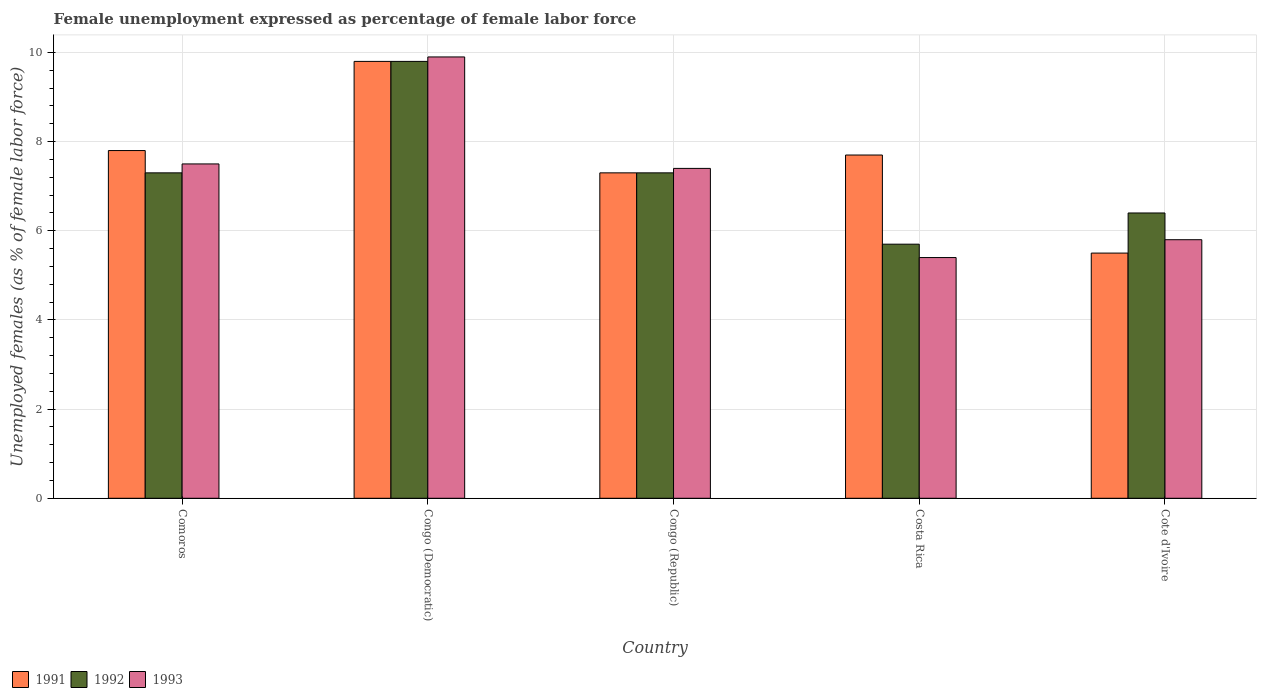How many different coloured bars are there?
Provide a succinct answer. 3. Are the number of bars per tick equal to the number of legend labels?
Offer a very short reply. Yes. What is the label of the 3rd group of bars from the left?
Your answer should be very brief. Congo (Republic). In how many cases, is the number of bars for a given country not equal to the number of legend labels?
Offer a terse response. 0. What is the unemployment in females in in 1993 in Congo (Republic)?
Your answer should be very brief. 7.4. Across all countries, what is the maximum unemployment in females in in 1992?
Your response must be concise. 9.8. Across all countries, what is the minimum unemployment in females in in 1992?
Your response must be concise. 5.7. In which country was the unemployment in females in in 1992 maximum?
Ensure brevity in your answer.  Congo (Democratic). What is the total unemployment in females in in 1992 in the graph?
Give a very brief answer. 36.5. What is the difference between the unemployment in females in in 1991 in Congo (Democratic) and that in Congo (Republic)?
Keep it short and to the point. 2.5. What is the difference between the unemployment in females in in 1992 in Congo (Republic) and the unemployment in females in in 1993 in Cote d'Ivoire?
Keep it short and to the point. 1.5. What is the average unemployment in females in in 1991 per country?
Provide a short and direct response. 7.62. What is the difference between the unemployment in females in of/in 1991 and unemployment in females in of/in 1993 in Comoros?
Make the answer very short. 0.3. What is the ratio of the unemployment in females in in 1991 in Comoros to that in Congo (Democratic)?
Your answer should be very brief. 0.8. Is the difference between the unemployment in females in in 1991 in Comoros and Congo (Republic) greater than the difference between the unemployment in females in in 1993 in Comoros and Congo (Republic)?
Keep it short and to the point. Yes. What is the difference between the highest and the second highest unemployment in females in in 1993?
Offer a terse response. 2.5. What is the difference between the highest and the lowest unemployment in females in in 1993?
Provide a succinct answer. 4.5. What does the 1st bar from the left in Congo (Republic) represents?
Provide a short and direct response. 1991. Are all the bars in the graph horizontal?
Ensure brevity in your answer.  No. What is the difference between two consecutive major ticks on the Y-axis?
Your answer should be compact. 2. Does the graph contain grids?
Your answer should be compact. Yes. Where does the legend appear in the graph?
Your answer should be compact. Bottom left. How many legend labels are there?
Ensure brevity in your answer.  3. What is the title of the graph?
Provide a short and direct response. Female unemployment expressed as percentage of female labor force. What is the label or title of the X-axis?
Make the answer very short. Country. What is the label or title of the Y-axis?
Your response must be concise. Unemployed females (as % of female labor force). What is the Unemployed females (as % of female labor force) of 1991 in Comoros?
Ensure brevity in your answer.  7.8. What is the Unemployed females (as % of female labor force) in 1992 in Comoros?
Your response must be concise. 7.3. What is the Unemployed females (as % of female labor force) in 1991 in Congo (Democratic)?
Your response must be concise. 9.8. What is the Unemployed females (as % of female labor force) of 1992 in Congo (Democratic)?
Your answer should be very brief. 9.8. What is the Unemployed females (as % of female labor force) in 1993 in Congo (Democratic)?
Offer a very short reply. 9.9. What is the Unemployed females (as % of female labor force) of 1991 in Congo (Republic)?
Provide a succinct answer. 7.3. What is the Unemployed females (as % of female labor force) in 1992 in Congo (Republic)?
Make the answer very short. 7.3. What is the Unemployed females (as % of female labor force) in 1993 in Congo (Republic)?
Your answer should be compact. 7.4. What is the Unemployed females (as % of female labor force) in 1991 in Costa Rica?
Your answer should be very brief. 7.7. What is the Unemployed females (as % of female labor force) of 1992 in Costa Rica?
Offer a very short reply. 5.7. What is the Unemployed females (as % of female labor force) in 1993 in Costa Rica?
Make the answer very short. 5.4. What is the Unemployed females (as % of female labor force) of 1992 in Cote d'Ivoire?
Keep it short and to the point. 6.4. What is the Unemployed females (as % of female labor force) of 1993 in Cote d'Ivoire?
Offer a very short reply. 5.8. Across all countries, what is the maximum Unemployed females (as % of female labor force) in 1991?
Your answer should be very brief. 9.8. Across all countries, what is the maximum Unemployed females (as % of female labor force) in 1992?
Provide a short and direct response. 9.8. Across all countries, what is the maximum Unemployed females (as % of female labor force) in 1993?
Make the answer very short. 9.9. Across all countries, what is the minimum Unemployed females (as % of female labor force) of 1991?
Ensure brevity in your answer.  5.5. Across all countries, what is the minimum Unemployed females (as % of female labor force) of 1992?
Offer a very short reply. 5.7. Across all countries, what is the minimum Unemployed females (as % of female labor force) of 1993?
Ensure brevity in your answer.  5.4. What is the total Unemployed females (as % of female labor force) in 1991 in the graph?
Ensure brevity in your answer.  38.1. What is the total Unemployed females (as % of female labor force) in 1992 in the graph?
Provide a short and direct response. 36.5. What is the difference between the Unemployed females (as % of female labor force) of 1991 in Comoros and that in Congo (Democratic)?
Your response must be concise. -2. What is the difference between the Unemployed females (as % of female labor force) in 1992 in Comoros and that in Congo (Democratic)?
Your answer should be very brief. -2.5. What is the difference between the Unemployed females (as % of female labor force) in 1993 in Comoros and that in Congo (Democratic)?
Your response must be concise. -2.4. What is the difference between the Unemployed females (as % of female labor force) in 1991 in Comoros and that in Congo (Republic)?
Provide a succinct answer. 0.5. What is the difference between the Unemployed females (as % of female labor force) of 1992 in Comoros and that in Congo (Republic)?
Offer a very short reply. 0. What is the difference between the Unemployed females (as % of female labor force) of 1993 in Comoros and that in Congo (Republic)?
Provide a succinct answer. 0.1. What is the difference between the Unemployed females (as % of female labor force) of 1991 in Comoros and that in Costa Rica?
Ensure brevity in your answer.  0.1. What is the difference between the Unemployed females (as % of female labor force) in 1992 in Comoros and that in Costa Rica?
Your answer should be very brief. 1.6. What is the difference between the Unemployed females (as % of female labor force) of 1993 in Congo (Democratic) and that in Costa Rica?
Your answer should be compact. 4.5. What is the difference between the Unemployed females (as % of female labor force) in 1993 in Congo (Democratic) and that in Cote d'Ivoire?
Your answer should be very brief. 4.1. What is the difference between the Unemployed females (as % of female labor force) in 1991 in Congo (Republic) and that in Costa Rica?
Make the answer very short. -0.4. What is the difference between the Unemployed females (as % of female labor force) in 1992 in Congo (Republic) and that in Costa Rica?
Offer a very short reply. 1.6. What is the difference between the Unemployed females (as % of female labor force) of 1993 in Congo (Republic) and that in Costa Rica?
Your response must be concise. 2. What is the difference between the Unemployed females (as % of female labor force) of 1992 in Congo (Republic) and that in Cote d'Ivoire?
Keep it short and to the point. 0.9. What is the difference between the Unemployed females (as % of female labor force) of 1993 in Congo (Republic) and that in Cote d'Ivoire?
Keep it short and to the point. 1.6. What is the difference between the Unemployed females (as % of female labor force) in 1993 in Costa Rica and that in Cote d'Ivoire?
Offer a terse response. -0.4. What is the difference between the Unemployed females (as % of female labor force) in 1991 in Comoros and the Unemployed females (as % of female labor force) in 1992 in Congo (Democratic)?
Provide a succinct answer. -2. What is the difference between the Unemployed females (as % of female labor force) in 1992 in Comoros and the Unemployed females (as % of female labor force) in 1993 in Congo (Democratic)?
Ensure brevity in your answer.  -2.6. What is the difference between the Unemployed females (as % of female labor force) in 1992 in Comoros and the Unemployed females (as % of female labor force) in 1993 in Congo (Republic)?
Provide a short and direct response. -0.1. What is the difference between the Unemployed females (as % of female labor force) in 1991 in Comoros and the Unemployed females (as % of female labor force) in 1992 in Costa Rica?
Offer a very short reply. 2.1. What is the difference between the Unemployed females (as % of female labor force) in 1992 in Comoros and the Unemployed females (as % of female labor force) in 1993 in Costa Rica?
Provide a short and direct response. 1.9. What is the difference between the Unemployed females (as % of female labor force) of 1991 in Comoros and the Unemployed females (as % of female labor force) of 1992 in Cote d'Ivoire?
Keep it short and to the point. 1.4. What is the difference between the Unemployed females (as % of female labor force) of 1991 in Comoros and the Unemployed females (as % of female labor force) of 1993 in Cote d'Ivoire?
Give a very brief answer. 2. What is the difference between the Unemployed females (as % of female labor force) in 1991 in Congo (Democratic) and the Unemployed females (as % of female labor force) in 1993 in Congo (Republic)?
Provide a succinct answer. 2.4. What is the difference between the Unemployed females (as % of female labor force) of 1992 in Congo (Democratic) and the Unemployed females (as % of female labor force) of 1993 in Congo (Republic)?
Offer a very short reply. 2.4. What is the difference between the Unemployed females (as % of female labor force) of 1992 in Congo (Democratic) and the Unemployed females (as % of female labor force) of 1993 in Costa Rica?
Offer a very short reply. 4.4. What is the difference between the Unemployed females (as % of female labor force) in 1991 in Congo (Democratic) and the Unemployed females (as % of female labor force) in 1993 in Cote d'Ivoire?
Provide a succinct answer. 4. What is the difference between the Unemployed females (as % of female labor force) in 1991 in Congo (Republic) and the Unemployed females (as % of female labor force) in 1993 in Costa Rica?
Ensure brevity in your answer.  1.9. What is the difference between the Unemployed females (as % of female labor force) in 1991 in Congo (Republic) and the Unemployed females (as % of female labor force) in 1992 in Cote d'Ivoire?
Keep it short and to the point. 0.9. What is the difference between the Unemployed females (as % of female labor force) in 1992 in Congo (Republic) and the Unemployed females (as % of female labor force) in 1993 in Cote d'Ivoire?
Give a very brief answer. 1.5. What is the difference between the Unemployed females (as % of female labor force) in 1991 in Costa Rica and the Unemployed females (as % of female labor force) in 1992 in Cote d'Ivoire?
Offer a very short reply. 1.3. What is the difference between the Unemployed females (as % of female labor force) of 1992 in Costa Rica and the Unemployed females (as % of female labor force) of 1993 in Cote d'Ivoire?
Your answer should be very brief. -0.1. What is the average Unemployed females (as % of female labor force) of 1991 per country?
Make the answer very short. 7.62. What is the average Unemployed females (as % of female labor force) in 1993 per country?
Provide a succinct answer. 7.2. What is the difference between the Unemployed females (as % of female labor force) of 1992 and Unemployed females (as % of female labor force) of 1993 in Comoros?
Your response must be concise. -0.2. What is the difference between the Unemployed females (as % of female labor force) in 1991 and Unemployed females (as % of female labor force) in 1992 in Congo (Democratic)?
Your answer should be compact. 0. What is the difference between the Unemployed females (as % of female labor force) in 1992 and Unemployed females (as % of female labor force) in 1993 in Congo (Republic)?
Provide a succinct answer. -0.1. What is the difference between the Unemployed females (as % of female labor force) of 1992 and Unemployed females (as % of female labor force) of 1993 in Costa Rica?
Offer a very short reply. 0.3. What is the difference between the Unemployed females (as % of female labor force) in 1991 and Unemployed females (as % of female labor force) in 1992 in Cote d'Ivoire?
Provide a short and direct response. -0.9. What is the difference between the Unemployed females (as % of female labor force) of 1991 and Unemployed females (as % of female labor force) of 1993 in Cote d'Ivoire?
Your response must be concise. -0.3. What is the difference between the Unemployed females (as % of female labor force) in 1992 and Unemployed females (as % of female labor force) in 1993 in Cote d'Ivoire?
Your answer should be very brief. 0.6. What is the ratio of the Unemployed females (as % of female labor force) of 1991 in Comoros to that in Congo (Democratic)?
Offer a very short reply. 0.8. What is the ratio of the Unemployed females (as % of female labor force) of 1992 in Comoros to that in Congo (Democratic)?
Keep it short and to the point. 0.74. What is the ratio of the Unemployed females (as % of female labor force) in 1993 in Comoros to that in Congo (Democratic)?
Ensure brevity in your answer.  0.76. What is the ratio of the Unemployed females (as % of female labor force) in 1991 in Comoros to that in Congo (Republic)?
Keep it short and to the point. 1.07. What is the ratio of the Unemployed females (as % of female labor force) in 1992 in Comoros to that in Congo (Republic)?
Provide a short and direct response. 1. What is the ratio of the Unemployed females (as % of female labor force) of 1993 in Comoros to that in Congo (Republic)?
Your response must be concise. 1.01. What is the ratio of the Unemployed females (as % of female labor force) in 1991 in Comoros to that in Costa Rica?
Your answer should be very brief. 1.01. What is the ratio of the Unemployed females (as % of female labor force) of 1992 in Comoros to that in Costa Rica?
Your answer should be compact. 1.28. What is the ratio of the Unemployed females (as % of female labor force) in 1993 in Comoros to that in Costa Rica?
Give a very brief answer. 1.39. What is the ratio of the Unemployed females (as % of female labor force) of 1991 in Comoros to that in Cote d'Ivoire?
Provide a short and direct response. 1.42. What is the ratio of the Unemployed females (as % of female labor force) in 1992 in Comoros to that in Cote d'Ivoire?
Provide a short and direct response. 1.14. What is the ratio of the Unemployed females (as % of female labor force) in 1993 in Comoros to that in Cote d'Ivoire?
Your answer should be compact. 1.29. What is the ratio of the Unemployed females (as % of female labor force) of 1991 in Congo (Democratic) to that in Congo (Republic)?
Your answer should be compact. 1.34. What is the ratio of the Unemployed females (as % of female labor force) of 1992 in Congo (Democratic) to that in Congo (Republic)?
Make the answer very short. 1.34. What is the ratio of the Unemployed females (as % of female labor force) of 1993 in Congo (Democratic) to that in Congo (Republic)?
Your response must be concise. 1.34. What is the ratio of the Unemployed females (as % of female labor force) of 1991 in Congo (Democratic) to that in Costa Rica?
Make the answer very short. 1.27. What is the ratio of the Unemployed females (as % of female labor force) of 1992 in Congo (Democratic) to that in Costa Rica?
Provide a short and direct response. 1.72. What is the ratio of the Unemployed females (as % of female labor force) of 1993 in Congo (Democratic) to that in Costa Rica?
Keep it short and to the point. 1.83. What is the ratio of the Unemployed females (as % of female labor force) of 1991 in Congo (Democratic) to that in Cote d'Ivoire?
Provide a succinct answer. 1.78. What is the ratio of the Unemployed females (as % of female labor force) in 1992 in Congo (Democratic) to that in Cote d'Ivoire?
Offer a very short reply. 1.53. What is the ratio of the Unemployed females (as % of female labor force) in 1993 in Congo (Democratic) to that in Cote d'Ivoire?
Provide a succinct answer. 1.71. What is the ratio of the Unemployed females (as % of female labor force) of 1991 in Congo (Republic) to that in Costa Rica?
Offer a terse response. 0.95. What is the ratio of the Unemployed females (as % of female labor force) in 1992 in Congo (Republic) to that in Costa Rica?
Offer a very short reply. 1.28. What is the ratio of the Unemployed females (as % of female labor force) in 1993 in Congo (Republic) to that in Costa Rica?
Make the answer very short. 1.37. What is the ratio of the Unemployed females (as % of female labor force) in 1991 in Congo (Republic) to that in Cote d'Ivoire?
Offer a very short reply. 1.33. What is the ratio of the Unemployed females (as % of female labor force) of 1992 in Congo (Republic) to that in Cote d'Ivoire?
Provide a succinct answer. 1.14. What is the ratio of the Unemployed females (as % of female labor force) of 1993 in Congo (Republic) to that in Cote d'Ivoire?
Ensure brevity in your answer.  1.28. What is the ratio of the Unemployed females (as % of female labor force) of 1991 in Costa Rica to that in Cote d'Ivoire?
Make the answer very short. 1.4. What is the ratio of the Unemployed females (as % of female labor force) in 1992 in Costa Rica to that in Cote d'Ivoire?
Your answer should be compact. 0.89. What is the difference between the highest and the second highest Unemployed females (as % of female labor force) in 1993?
Provide a short and direct response. 2.4. What is the difference between the highest and the lowest Unemployed females (as % of female labor force) of 1991?
Your response must be concise. 4.3. What is the difference between the highest and the lowest Unemployed females (as % of female labor force) in 1992?
Give a very brief answer. 4.1. What is the difference between the highest and the lowest Unemployed females (as % of female labor force) in 1993?
Your response must be concise. 4.5. 